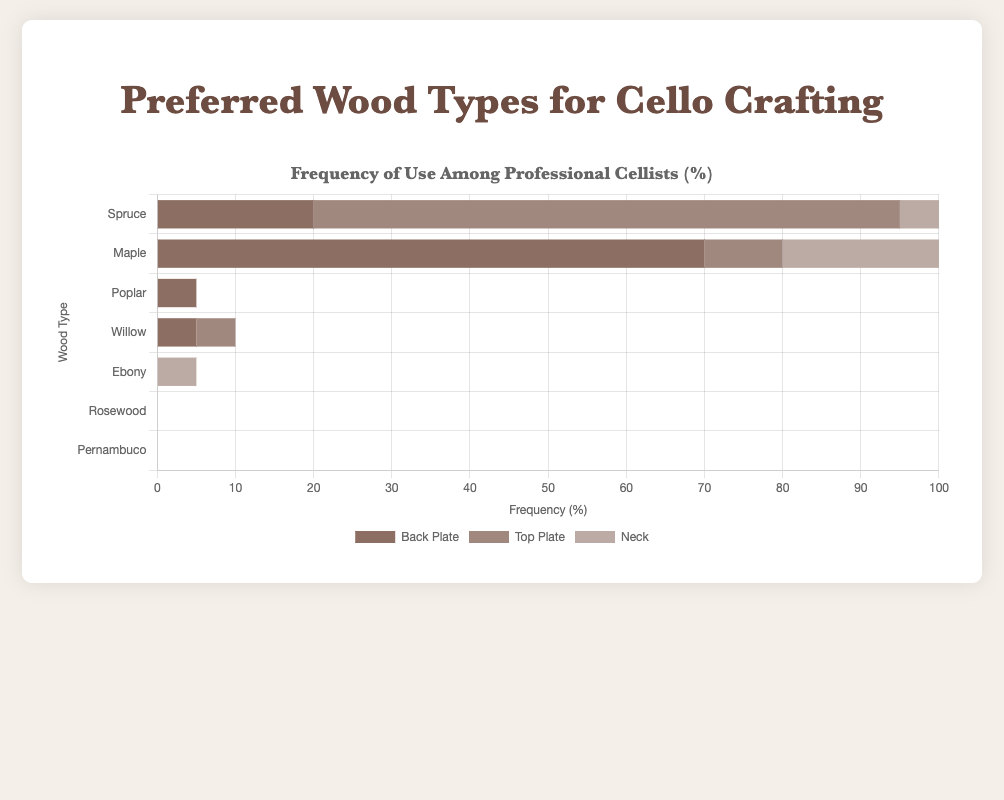Which wood type is used most frequently for the neck component? To identify the wood type used most frequently for the neck, we look at the lengths of the stacked bars specifically for the neck category. The longest bar segment in the neck category is for Maple.
Answer: Maple Which wood type has the highest total usage across all components? To find the wood type with the highest total usage, sum the frequencies of use across the back plate, top plate, and neck for each wood type. Maple: 70+10+80=160, Spruce: 20+75+15=110, Poplar: 5+0+0=5, Willow: 5+5+0=10, Ebony: 0+0+5=5, Rosewood: 0+0+0=0, Pernambuco: 0+0+0=0. The highest sum is for Maple.
Answer: Maple What is the combined usage percentage of Poplar and Willow for back plates? To find the combined usage percentage, sum the back plate values for Poplar and Willow. Poplar has 5% and Willow has 5%, so 5+5=10%.
Answer: 10% Compare the usage of Spruce and Maple for the top plate. Which one is used more and by how much? Compare the top plate values for Spruce (75%) and Maple (10%). Spruce is used more and the difference is 75-10=65%.
Answer: 65% more Spruce What percentage of cellists use Ebony for any component? Ebony is used for the neck only, with a frequency of 5% as indicated in the figure.
Answer: 5% What wood type has the lowest total frequency of use across all components, excluding those with zero usage? Excluding Rosewood and Pernambuco which have zero total frequency, calculate the total usage for the other types. Ebony has 5%, Poplar has 5%, and Willow has 10%. The lowest is shared by Ebony and Poplar, both at 5%.
Answer: Ebony and Poplar What is the average usage of Spruce across the back plate, top plate, and neck? To find the average usage, sum the percentages for Spruce (20+75+15) and then divide by 3. The sum is 110%, and the average is 110/3 ≈ 36.67%.
Answer: 36.67% If a cello maker decides to use either Poplar or Willow for the back plate, what is the probability that they choose Willow? Given that the frequencies are equal, the choice between Poplar and Willow is equally likely, so the probability is 1 out of 2, or 50%.
Answer: 50% List all wood types that are used exclusively for one specific component, and specify which component. Review each wood type's usage, and find those with values in only one category. Poplar is used only for back plate, Ebony only for neck, Rosewood and Pernambuco are not used at all.
Answer: Poplar (back plate), Ebony (neck) Which component has the most diverse range of wood types in use? Count the number of different wood types used for each component. Back plate uses Spruce, Maple, Poplar, Willow. Top plate uses Spruce, Maple, Willow. Neck uses Spruce, Maple, Ebony. Back plate has the most diverse range with 4 types.
Answer: Back plate 